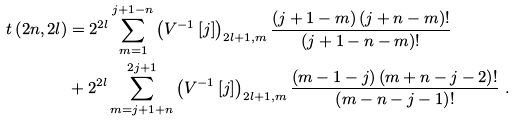<formula> <loc_0><loc_0><loc_500><loc_500>t \left ( 2 n , 2 l \right ) & = 2 ^ { 2 l } \sum _ { m = 1 } ^ { j + 1 - n } \left ( V ^ { - 1 } \left [ j \right ] \right ) _ { 2 l + 1 , m } \frac { \left ( j + 1 - m \right ) \left ( j + n - m \right ) ! } { \left ( j + 1 - n - m \right ) ! } \\ & + 2 ^ { 2 l } \sum _ { m = j + 1 + n } ^ { 2 j + 1 } \left ( V ^ { - 1 } \left [ j \right ] \right ) _ { 2 l + 1 , m } \frac { \left ( m - 1 - j \right ) \left ( m + n - j - 2 \right ) ! } { \left ( m - n - j - 1 \right ) ! } \ .</formula> 